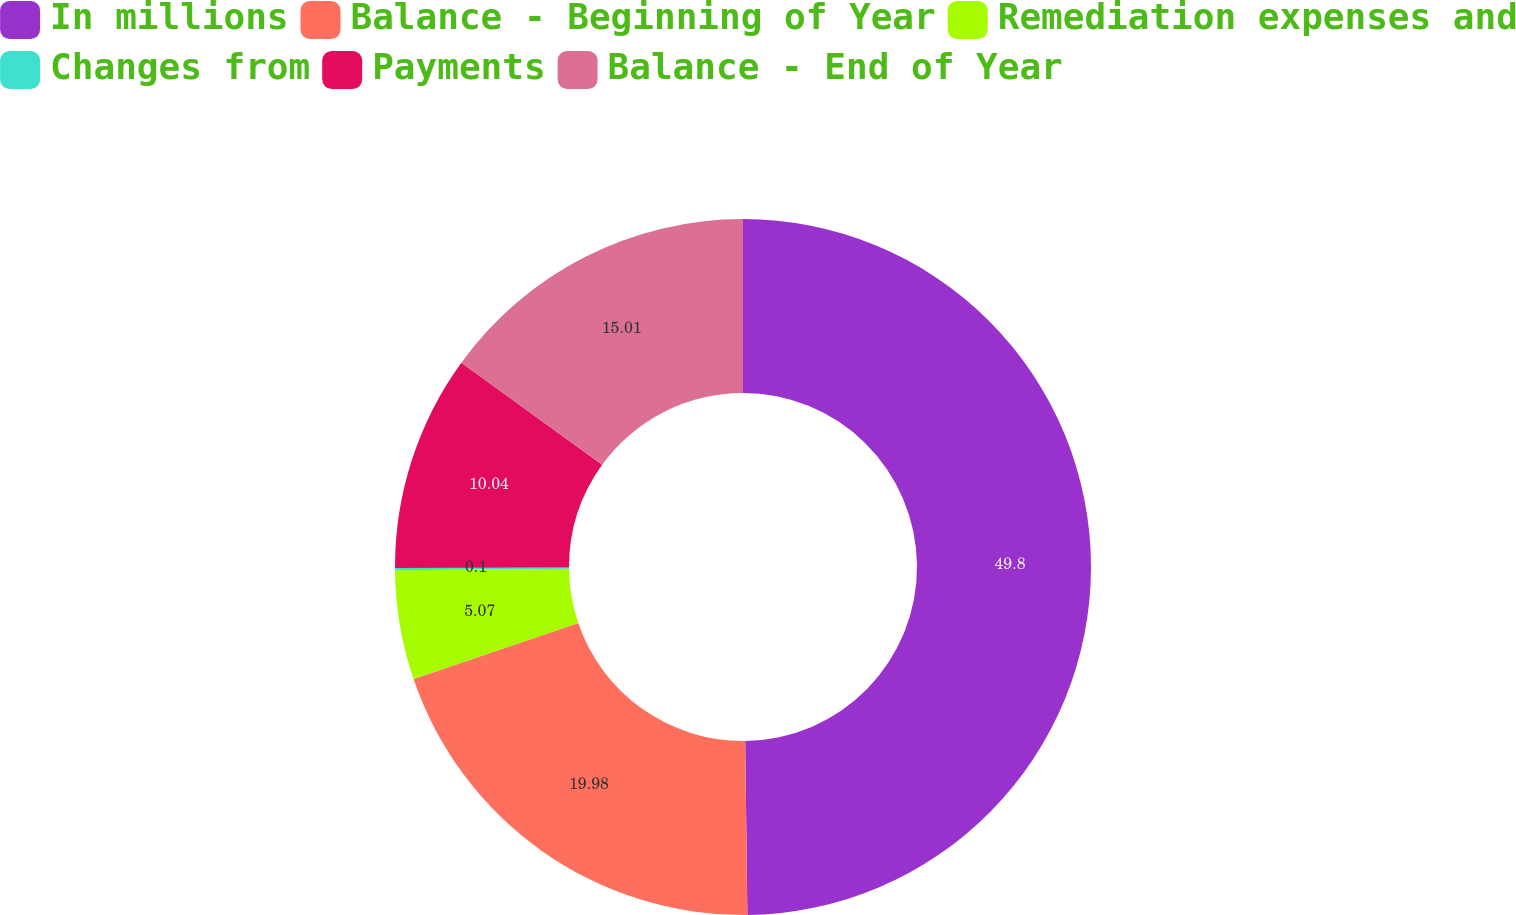<chart> <loc_0><loc_0><loc_500><loc_500><pie_chart><fcel>In millions<fcel>Balance - Beginning of Year<fcel>Remediation expenses and<fcel>Changes from<fcel>Payments<fcel>Balance - End of Year<nl><fcel>49.8%<fcel>19.98%<fcel>5.07%<fcel>0.1%<fcel>10.04%<fcel>15.01%<nl></chart> 